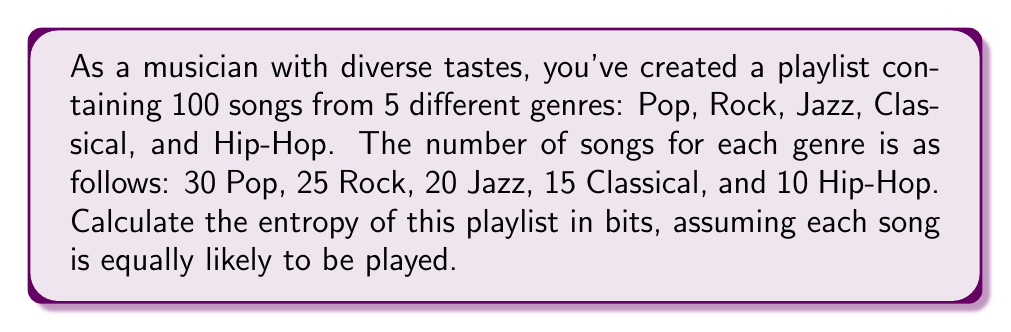Can you solve this math problem? To calculate the entropy of the playlist, we'll use the Shannon entropy formula:

$$S = -\sum_{i=1}^{n} p_i \log_2(p_i)$$

Where $S$ is the entropy, $n$ is the number of genres, and $p_i$ is the probability of selecting a song from genre $i$.

Step 1: Calculate the probabilities for each genre
Pop: $p_1 = 30/100 = 0.3$
Rock: $p_2 = 25/100 = 0.25$
Jazz: $p_3 = 20/100 = 0.2$
Classical: $p_4 = 15/100 = 0.15$
Hip-Hop: $p_5 = 10/100 = 0.1$

Step 2: Calculate each term in the summation
Pop: $-0.3 \log_2(0.3) \approx 0.5211$
Rock: $-0.25 \log_2(0.25) \approx 0.5$
Jazz: $-0.2 \log_2(0.2) \approx 0.4644$
Classical: $-0.15 \log_2(0.15) \approx 0.4101$
Hip-Hop: $-0.1 \log_2(0.1) \approx 0.3322$

Step 3: Sum all terms
$$S = 0.5211 + 0.5 + 0.4644 + 0.4101 + 0.3322 = 2.2278$$

Therefore, the entropy of the playlist is approximately 2.2278 bits.
Answer: 2.2278 bits 